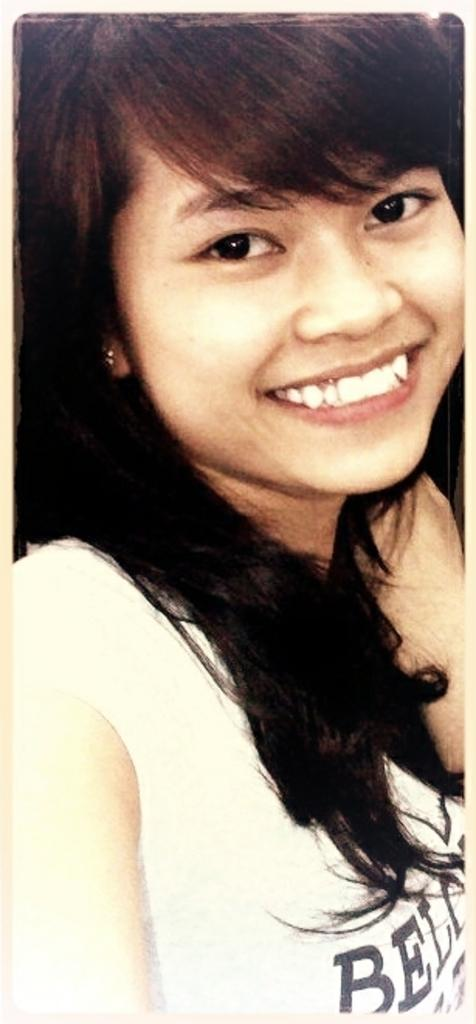Who is present in the image? There is a woman in the image. What type of cracker is being used as a caption for the woman's debt in the image? There is no cracker, caption, or mention of debt present in the image. 